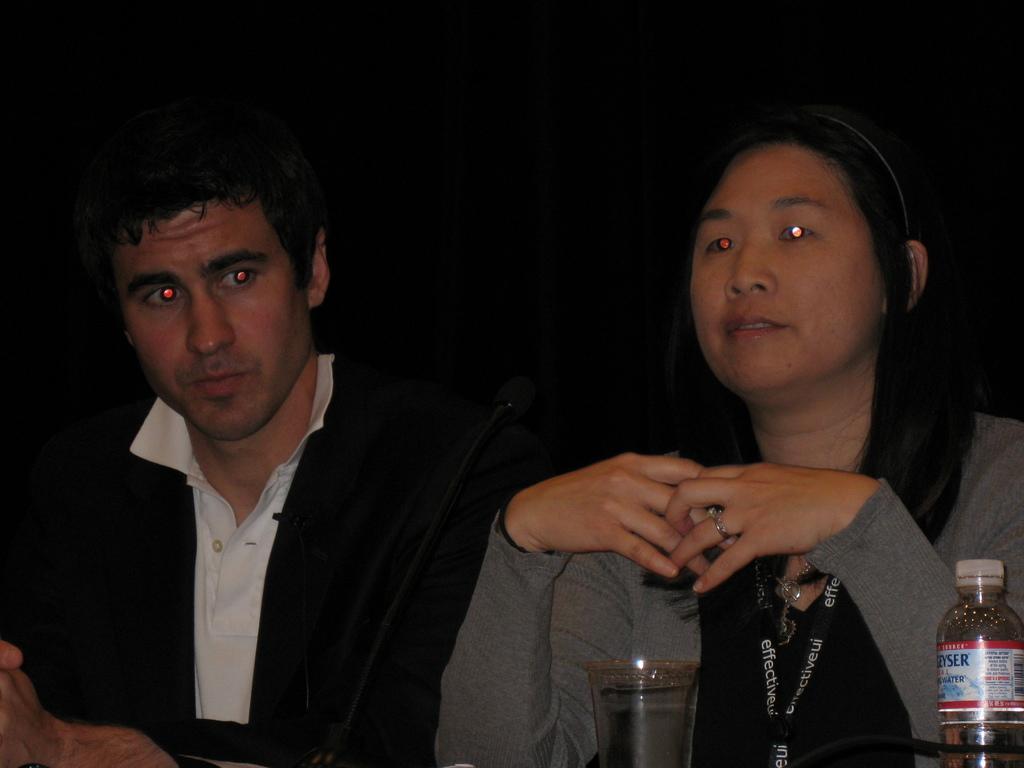Can you describe this image briefly? There is a man and a woman. Woman is wearing a tag. In front of her there is a mic, glass and a bottle. In the background it is dark. 